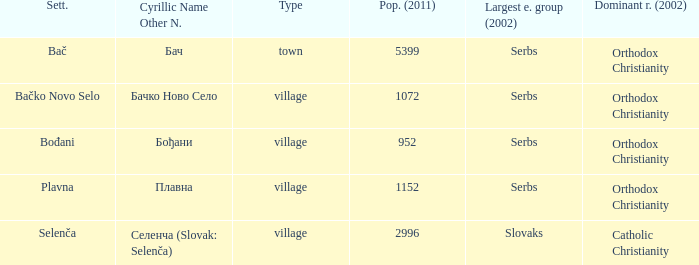Parse the table in full. {'header': ['Sett.', 'Cyrillic Name Other N.', 'Type', 'Pop. (2011)', 'Largest e. group (2002)', 'Dominant r. (2002)'], 'rows': [['Bač', 'Бач', 'town', '5399', 'Serbs', 'Orthodox Christianity'], ['Bačko Novo Selo', 'Бачко Ново Село', 'village', '1072', 'Serbs', 'Orthodox Christianity'], ['Bođani', 'Бођани', 'village', '952', 'Serbs', 'Orthodox Christianity'], ['Plavna', 'Плавна', 'village', '1152', 'Serbs', 'Orthodox Christianity'], ['Selenča', 'Селенча (Slovak: Selenča)', 'village', '2996', 'Slovaks', 'Catholic Christianity']]} What is the smallest population listed? 952.0. 